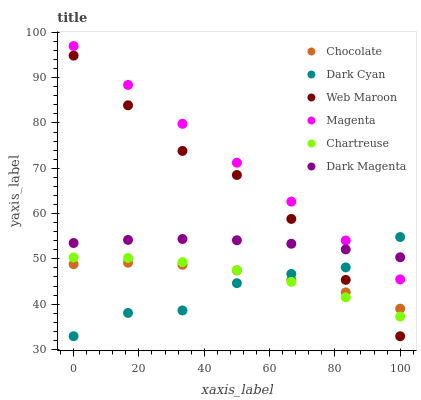Does Dark Cyan have the minimum area under the curve?
Answer yes or no. Yes. Does Magenta have the maximum area under the curve?
Answer yes or no. Yes. Does Web Maroon have the minimum area under the curve?
Answer yes or no. No. Does Web Maroon have the maximum area under the curve?
Answer yes or no. No. Is Magenta the smoothest?
Answer yes or no. Yes. Is Dark Cyan the roughest?
Answer yes or no. Yes. Is Web Maroon the smoothest?
Answer yes or no. No. Is Web Maroon the roughest?
Answer yes or no. No. Does Web Maroon have the lowest value?
Answer yes or no. Yes. Does Chocolate have the lowest value?
Answer yes or no. No. Does Magenta have the highest value?
Answer yes or no. Yes. Does Web Maroon have the highest value?
Answer yes or no. No. Is Chartreuse less than Magenta?
Answer yes or no. Yes. Is Magenta greater than Web Maroon?
Answer yes or no. Yes. Does Dark Cyan intersect Web Maroon?
Answer yes or no. Yes. Is Dark Cyan less than Web Maroon?
Answer yes or no. No. Is Dark Cyan greater than Web Maroon?
Answer yes or no. No. Does Chartreuse intersect Magenta?
Answer yes or no. No. 